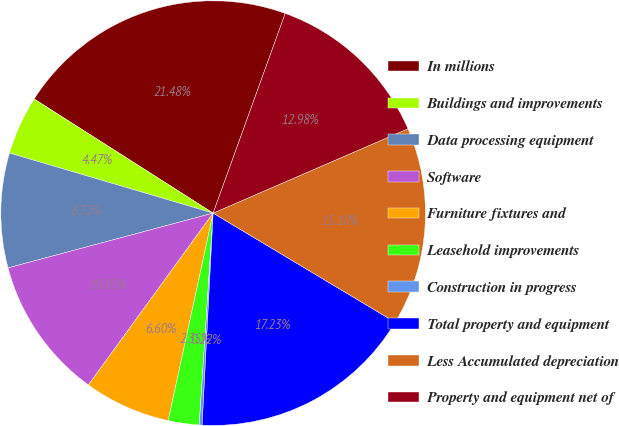Convert chart to OTSL. <chart><loc_0><loc_0><loc_500><loc_500><pie_chart><fcel>In millions<fcel>Buildings and improvements<fcel>Data processing equipment<fcel>Software<fcel>Furniture fixtures and<fcel>Leasehold improvements<fcel>Construction in progress<fcel>Total property and equipment<fcel>Less Accumulated depreciation<fcel>Property and equipment net of<nl><fcel>21.48%<fcel>4.47%<fcel>8.72%<fcel>10.85%<fcel>6.6%<fcel>2.35%<fcel>0.22%<fcel>17.23%<fcel>15.1%<fcel>12.98%<nl></chart> 